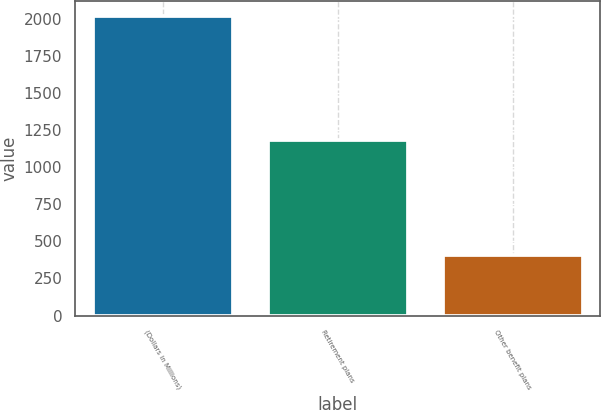<chart> <loc_0><loc_0><loc_500><loc_500><bar_chart><fcel>(Dollars in Millions)<fcel>Retirement plans<fcel>Other benefit plans<nl><fcel>2021<fcel>1182<fcel>411<nl></chart> 